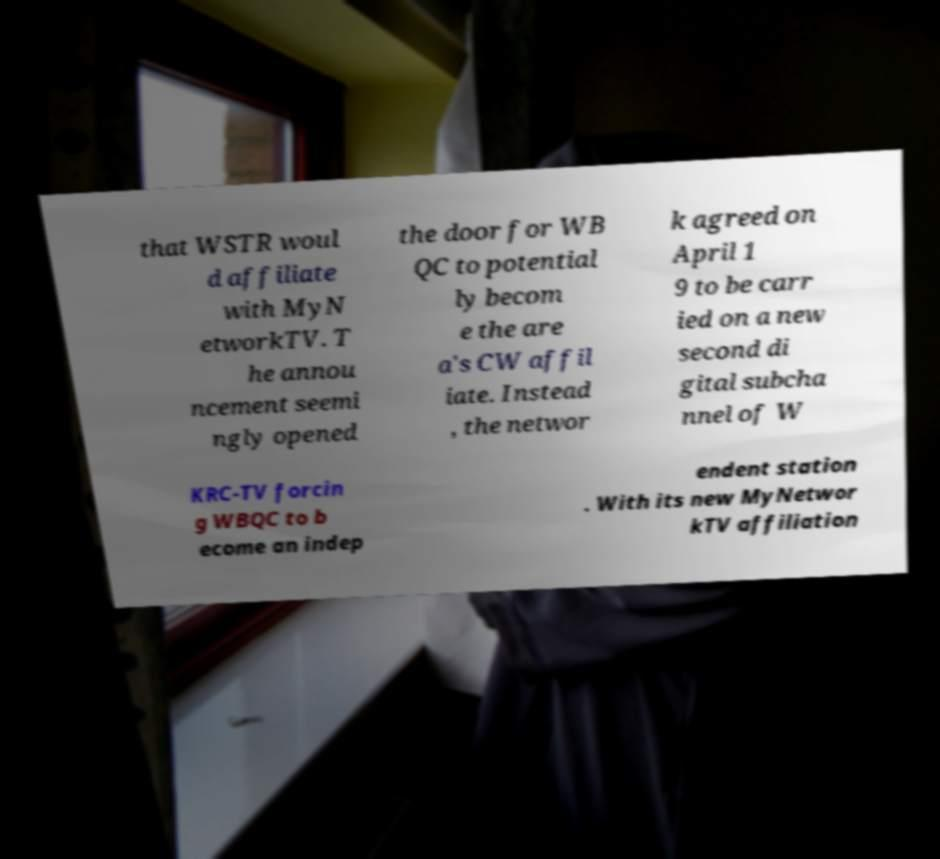Can you read and provide the text displayed in the image?This photo seems to have some interesting text. Can you extract and type it out for me? that WSTR woul d affiliate with MyN etworkTV. T he annou ncement seemi ngly opened the door for WB QC to potential ly becom e the are a's CW affil iate. Instead , the networ k agreed on April 1 9 to be carr ied on a new second di gital subcha nnel of W KRC-TV forcin g WBQC to b ecome an indep endent station . With its new MyNetwor kTV affiliation 